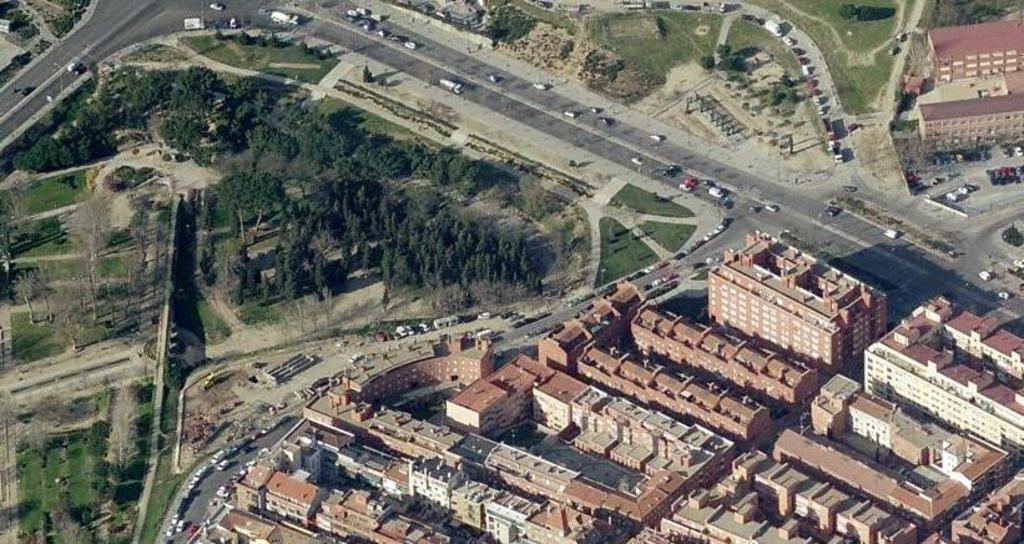What type of view is shown in the image? The image is an aerial view. What structures can be seen from this perspective? There are buildings visible in the image. What else can be seen on the ground? There are roads visible in the image. Are there any vehicles on the roads? Yes, there are cars on the roads. What else can be seen in the image besides buildings and roads? There are trees visible in the image. What organization is responsible for the placement of the finger in the image? There is no finger present in the image, so it is not possible to determine any organization's involvement. 